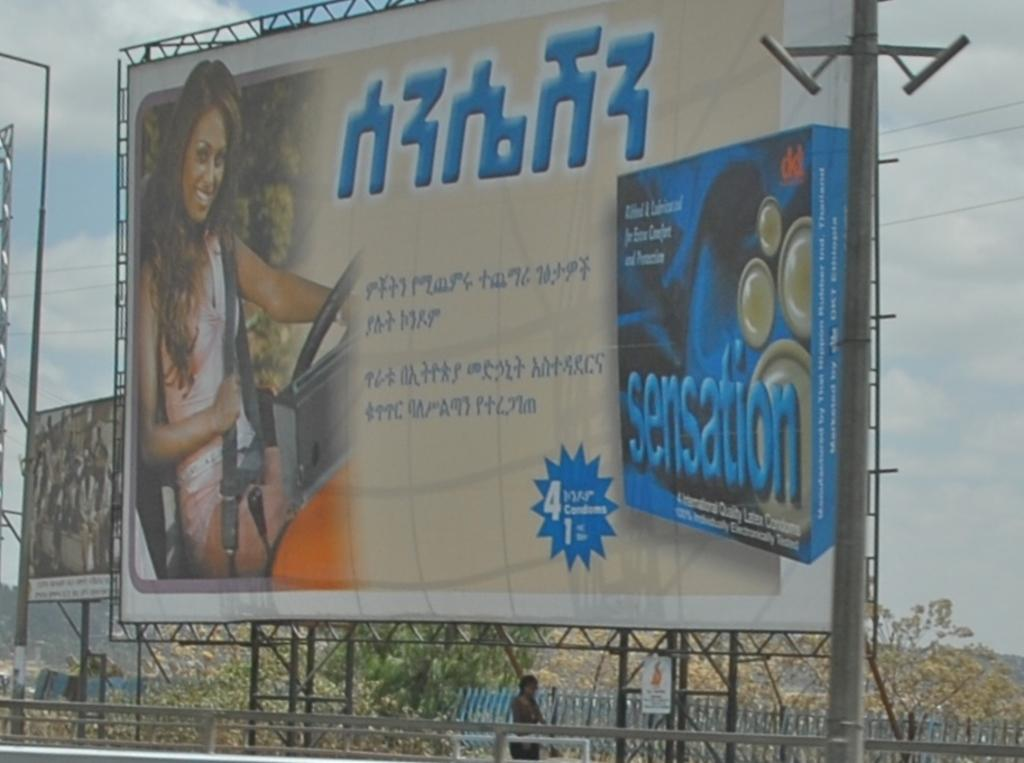<image>
Write a terse but informative summary of the picture. The product shown here gives you a great sensation if you take it 